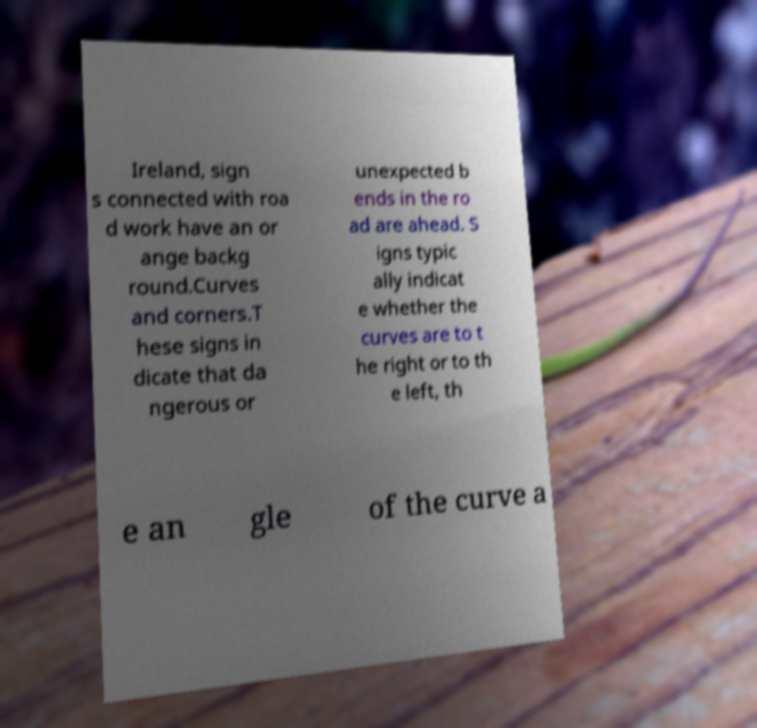For documentation purposes, I need the text within this image transcribed. Could you provide that? Ireland, sign s connected with roa d work have an or ange backg round.Curves and corners.T hese signs in dicate that da ngerous or unexpected b ends in the ro ad are ahead. S igns typic ally indicat e whether the curves are to t he right or to th e left, th e an gle of the curve a 